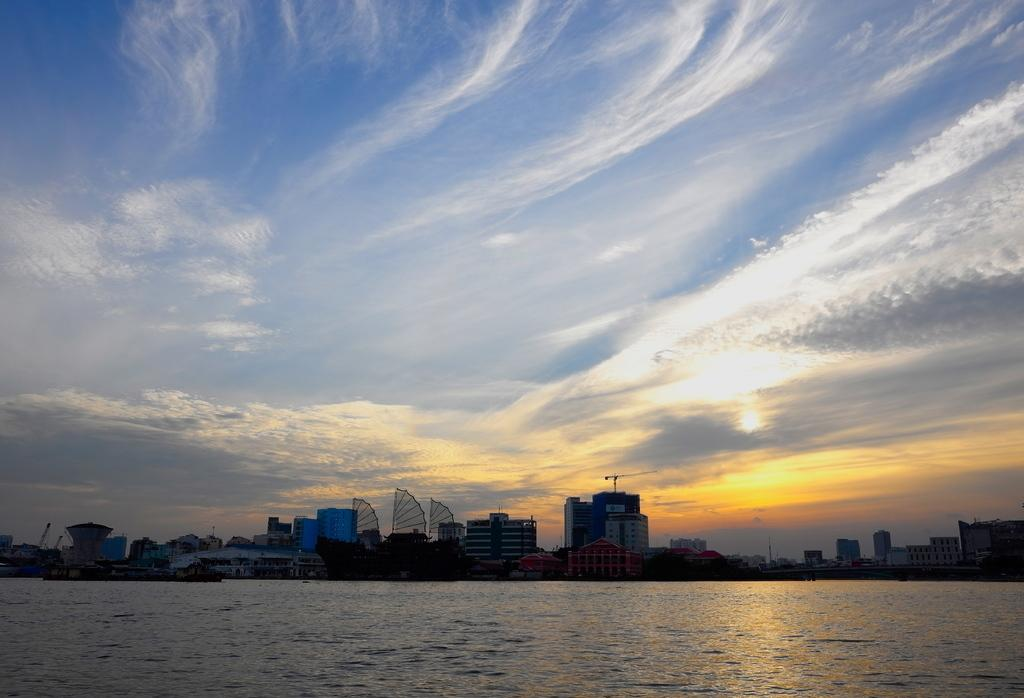What is visible in front of the image? There is water in front of the image. What can be seen in the distance in the image? There are buildings in the background of the image. What is visible in the sky at the top of the image? There are clouds in the sky at the top of the image. How many minutes does the turkey take to fly across the sky in the image? There is no turkey present in the image, so it is not possible to determine how long it would take to fly across the sky. 